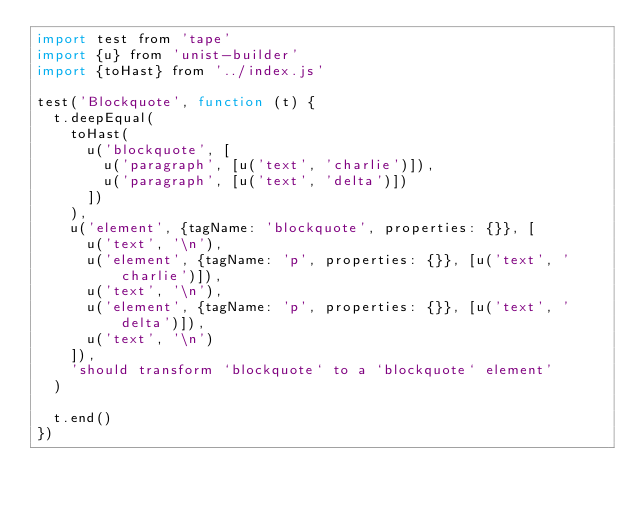<code> <loc_0><loc_0><loc_500><loc_500><_JavaScript_>import test from 'tape'
import {u} from 'unist-builder'
import {toHast} from '../index.js'

test('Blockquote', function (t) {
  t.deepEqual(
    toHast(
      u('blockquote', [
        u('paragraph', [u('text', 'charlie')]),
        u('paragraph', [u('text', 'delta')])
      ])
    ),
    u('element', {tagName: 'blockquote', properties: {}}, [
      u('text', '\n'),
      u('element', {tagName: 'p', properties: {}}, [u('text', 'charlie')]),
      u('text', '\n'),
      u('element', {tagName: 'p', properties: {}}, [u('text', 'delta')]),
      u('text', '\n')
    ]),
    'should transform `blockquote` to a `blockquote` element'
  )

  t.end()
})
</code> 